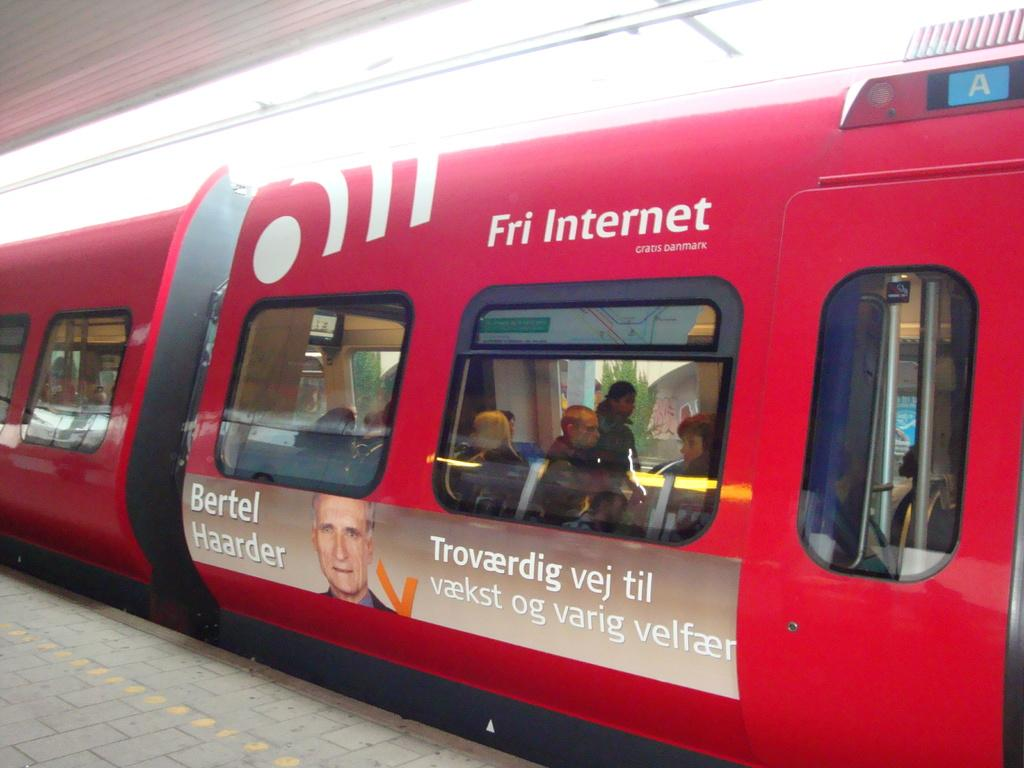What is located at the bottom of the image? There is a road at the bottom of the image. What mode of transportation can be seen in the image? There is a train in the image. What is present in the foreground of the image? There are glass windows in the foreground of the image. Who or what can be seen through the glass windows? People are visible through the glass windows. What type of natural scenery is visible in the background of the image? Trees are visible in the background of the image. How many amusement rides are present in the image? There are no amusement rides present in the image. What type of bikes can be seen in the image? There are no bikes visible in the image. 